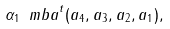Convert formula to latex. <formula><loc_0><loc_0><loc_500><loc_500>\alpha _ { 1 } { \ m b a } ^ { t } ( a _ { 4 } , a _ { 3 } , a _ { 2 } , a _ { 1 } ) ,</formula> 